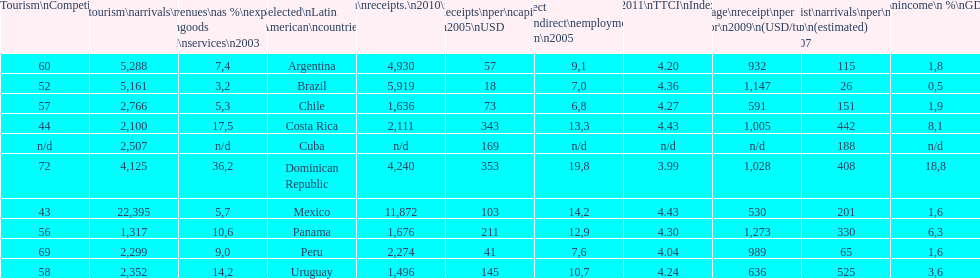Tourism income in latin american countries in 2003 was at most what percentage of gdp? 18,8. 